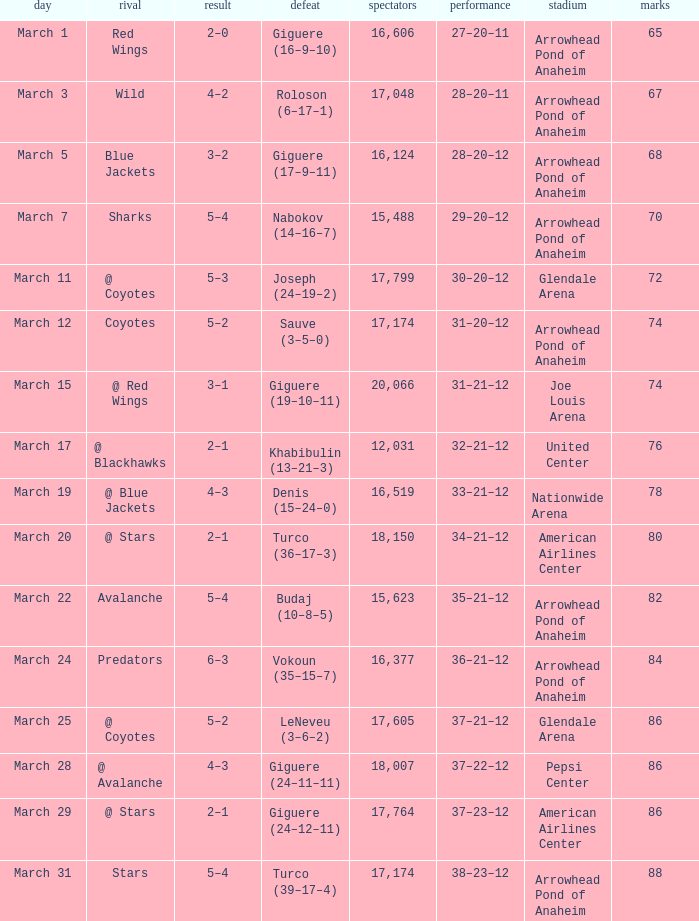What is the Attendance of the game with a Record of 37–21–12 and less than 86 Points? None. 